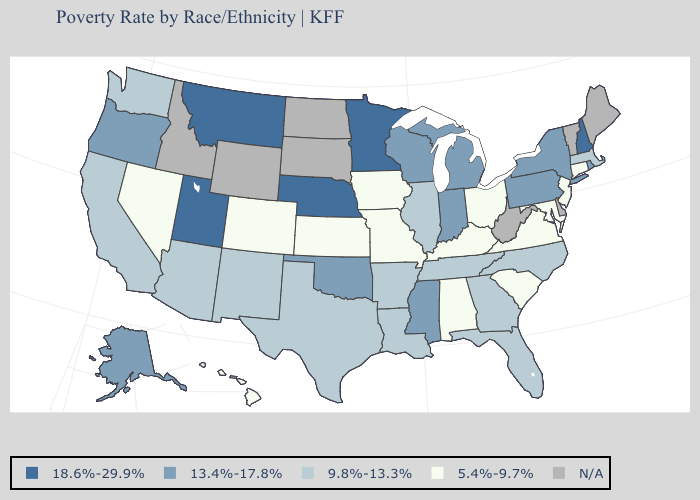Does Wisconsin have the highest value in the MidWest?
Write a very short answer. No. Which states hav the highest value in the West?
Be succinct. Montana, Utah. Name the states that have a value in the range 5.4%-9.7%?
Answer briefly. Alabama, Colorado, Connecticut, Hawaii, Iowa, Kansas, Kentucky, Maryland, Missouri, Nevada, New Jersey, Ohio, South Carolina, Virginia. What is the value of New Mexico?
Keep it brief. 9.8%-13.3%. Among the states that border Arizona , does Nevada have the highest value?
Quick response, please. No. Does the first symbol in the legend represent the smallest category?
Keep it brief. No. What is the highest value in states that border Louisiana?
Concise answer only. 13.4%-17.8%. Among the states that border Missouri , which have the highest value?
Short answer required. Nebraska. What is the value of Virginia?
Give a very brief answer. 5.4%-9.7%. What is the value of Florida?
Concise answer only. 9.8%-13.3%. Which states have the lowest value in the USA?
Quick response, please. Alabama, Colorado, Connecticut, Hawaii, Iowa, Kansas, Kentucky, Maryland, Missouri, Nevada, New Jersey, Ohio, South Carolina, Virginia. What is the lowest value in the West?
Concise answer only. 5.4%-9.7%. How many symbols are there in the legend?
Quick response, please. 5. Name the states that have a value in the range 18.6%-29.9%?
Concise answer only. Minnesota, Montana, Nebraska, New Hampshire, Utah. 